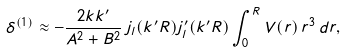<formula> <loc_0><loc_0><loc_500><loc_500>\delta ^ { ( 1 ) } \approx - \frac { 2 k k ^ { \prime } } { A ^ { 2 } + B ^ { 2 } } \, j _ { l } ( k ^ { \prime } R ) j _ { l } ^ { \prime } ( k ^ { \prime } R ) \int ^ { R } _ { 0 } V ( r ) \, r ^ { 3 } \, d r ,</formula> 